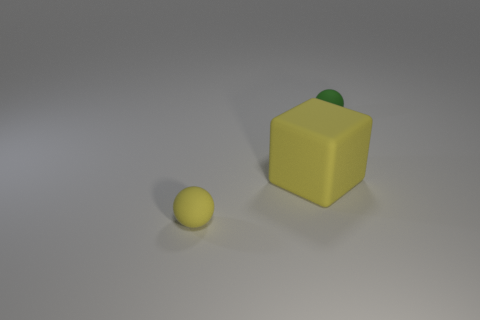There is another object that is the same size as the green matte object; what color is it?
Make the answer very short. Yellow. Is the number of small green rubber things that are to the left of the tiny yellow matte ball the same as the number of gray metal cylinders?
Provide a short and direct response. Yes. The small matte thing that is to the left of the tiny green thing to the right of the cube is what color?
Ensure brevity in your answer.  Yellow. There is a green matte ball to the right of the rubber sphere in front of the tiny green thing; how big is it?
Your answer should be very brief. Small. What size is the sphere that is the same color as the matte block?
Your response must be concise. Small. What number of other things are there of the same size as the yellow ball?
Offer a terse response. 1. The small thing that is in front of the green ball that is behind the small rubber ball to the left of the rubber cube is what color?
Provide a succinct answer. Yellow. What number of other objects are there of the same shape as the small green rubber thing?
Provide a succinct answer. 1. The tiny rubber thing that is in front of the green rubber ball has what shape?
Your response must be concise. Sphere. Are there any tiny yellow matte spheres behind the small object on the right side of the large matte thing?
Provide a short and direct response. No. 